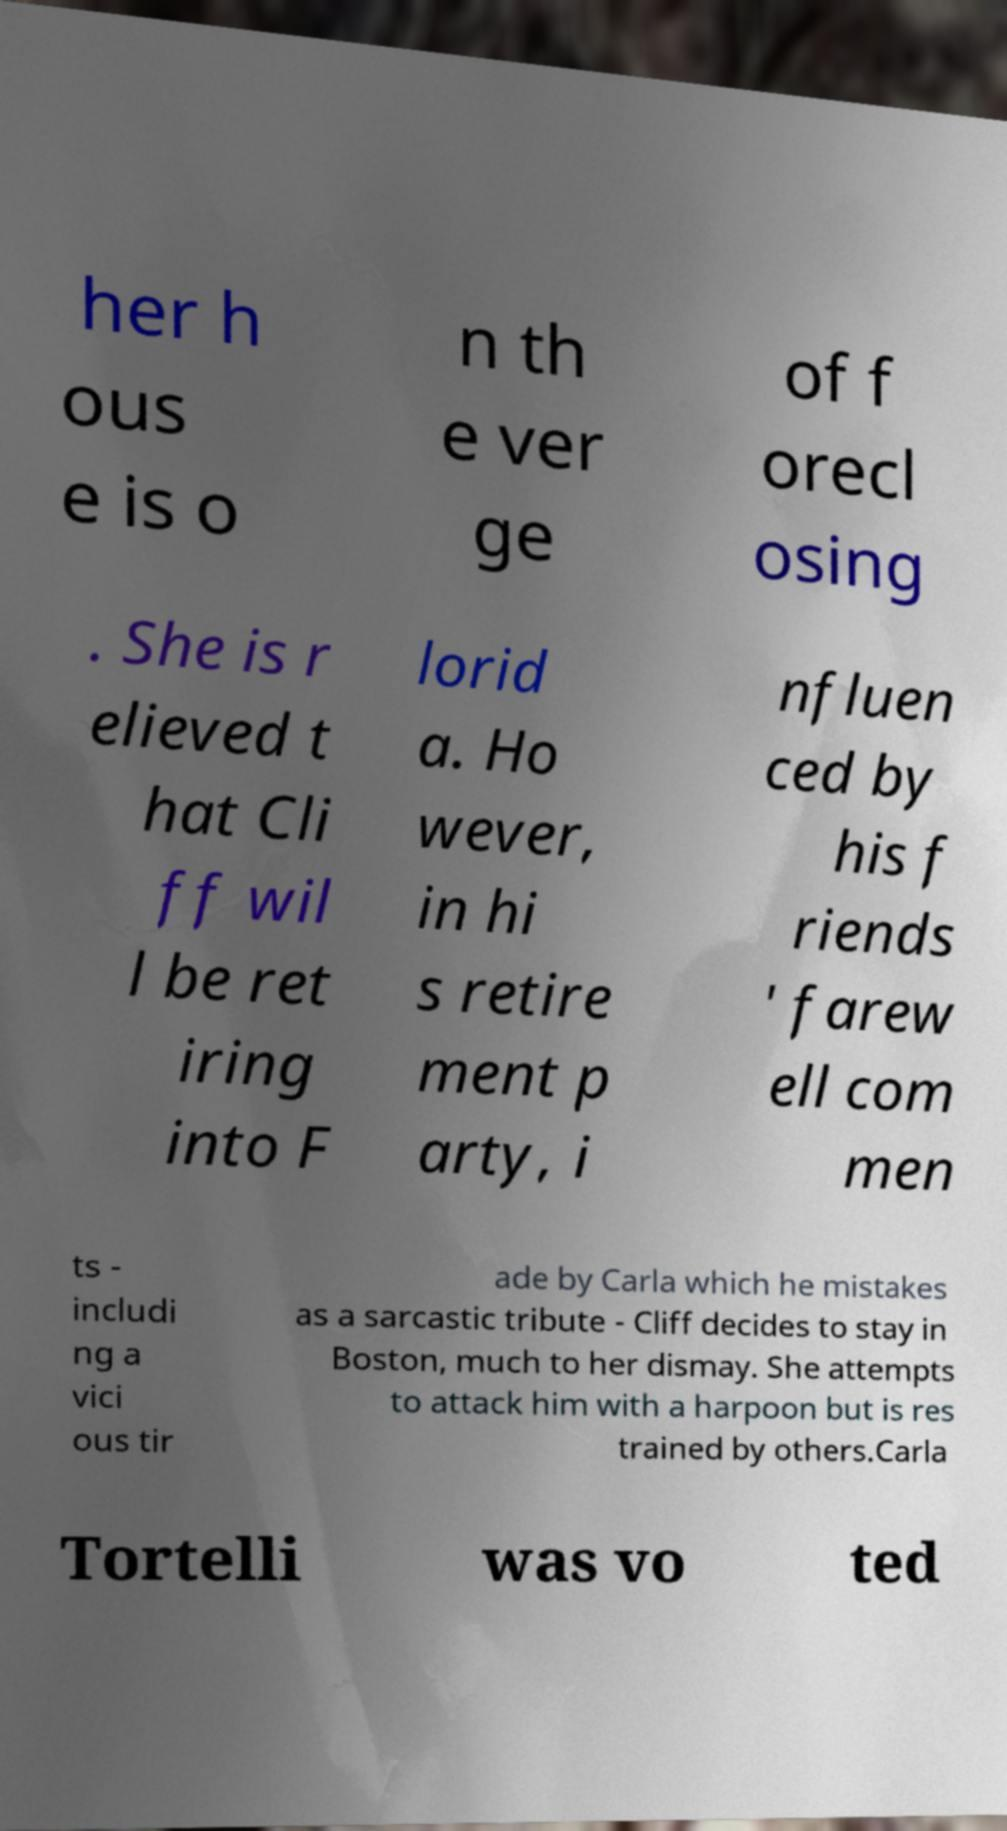Please read and relay the text visible in this image. What does it say? her h ous e is o n th e ver ge of f orecl osing . She is r elieved t hat Cli ff wil l be ret iring into F lorid a. Ho wever, in hi s retire ment p arty, i nfluen ced by his f riends ' farew ell com men ts - includi ng a vici ous tir ade by Carla which he mistakes as a sarcastic tribute - Cliff decides to stay in Boston, much to her dismay. She attempts to attack him with a harpoon but is res trained by others.Carla Tortelli was vo ted 